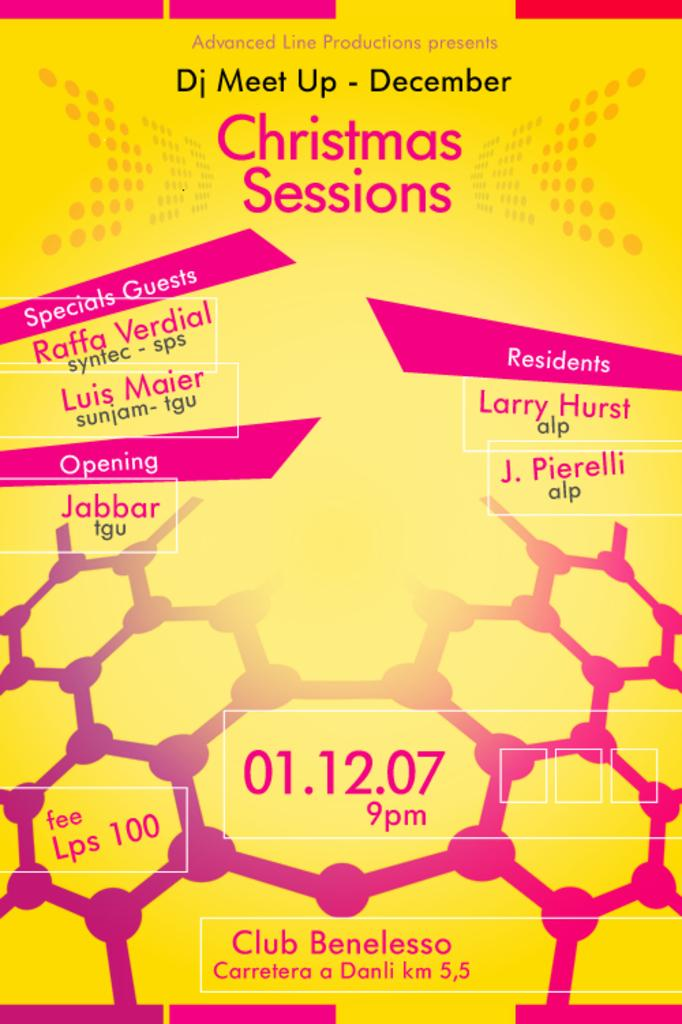<image>
Share a concise interpretation of the image provided. A poster for an event called "Christmas Sessions" features pink text on a yellow background. 